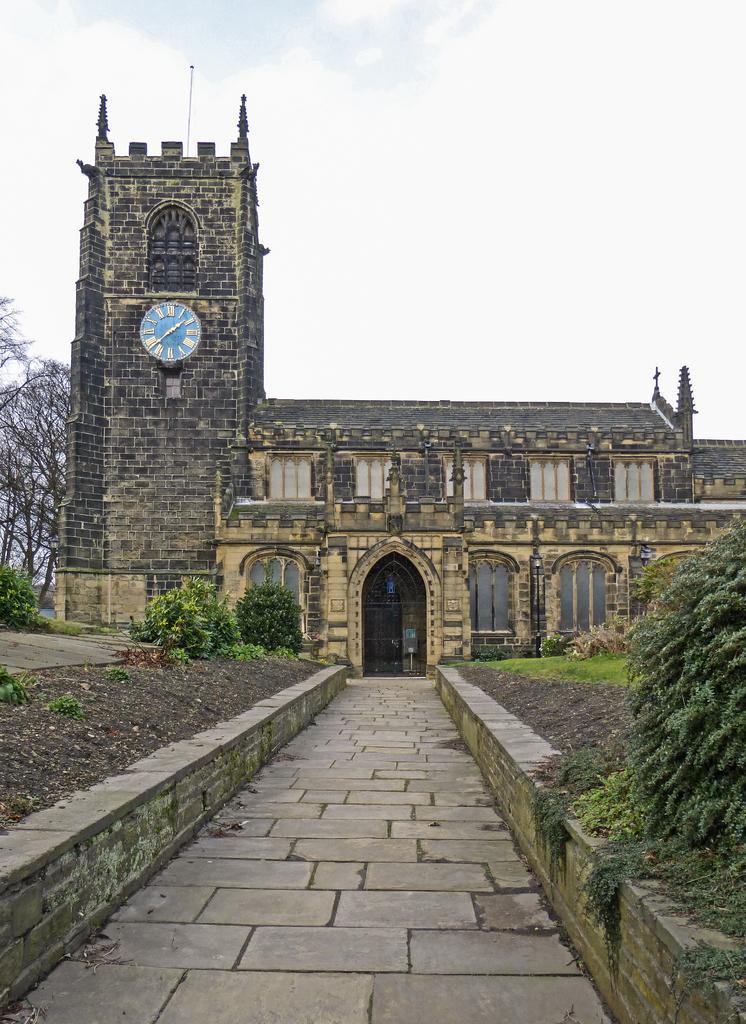In one or two sentences, can you explain what this image depicts? In this image there is a building with the clock in the middle. At the top there is the sky. At the bottom there is a pavement. There are small trees on either side of it. On the left side there are trees. 